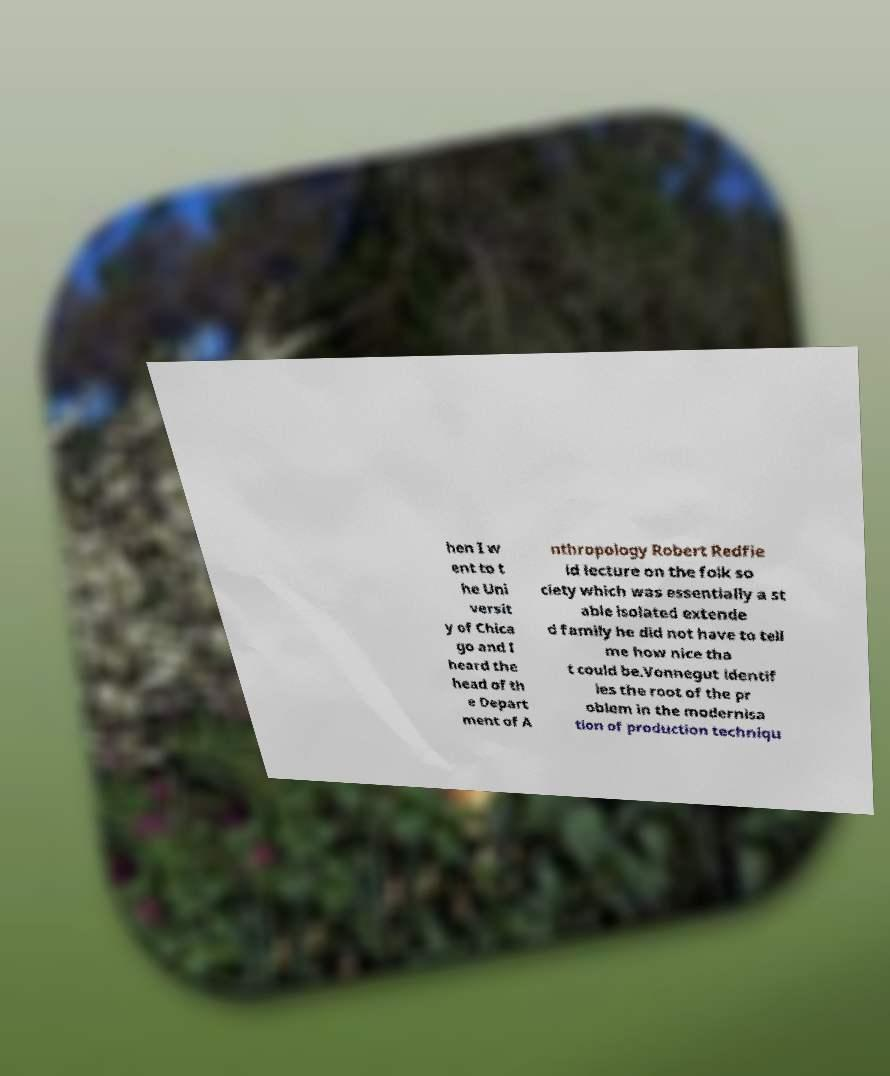Can you accurately transcribe the text from the provided image for me? hen I w ent to t he Uni versit y of Chica go and I heard the head of th e Depart ment of A nthropology Robert Redfie ld lecture on the folk so ciety which was essentially a st able isolated extende d family he did not have to tell me how nice tha t could be.Vonnegut identif ies the root of the pr oblem in the modernisa tion of production techniqu 